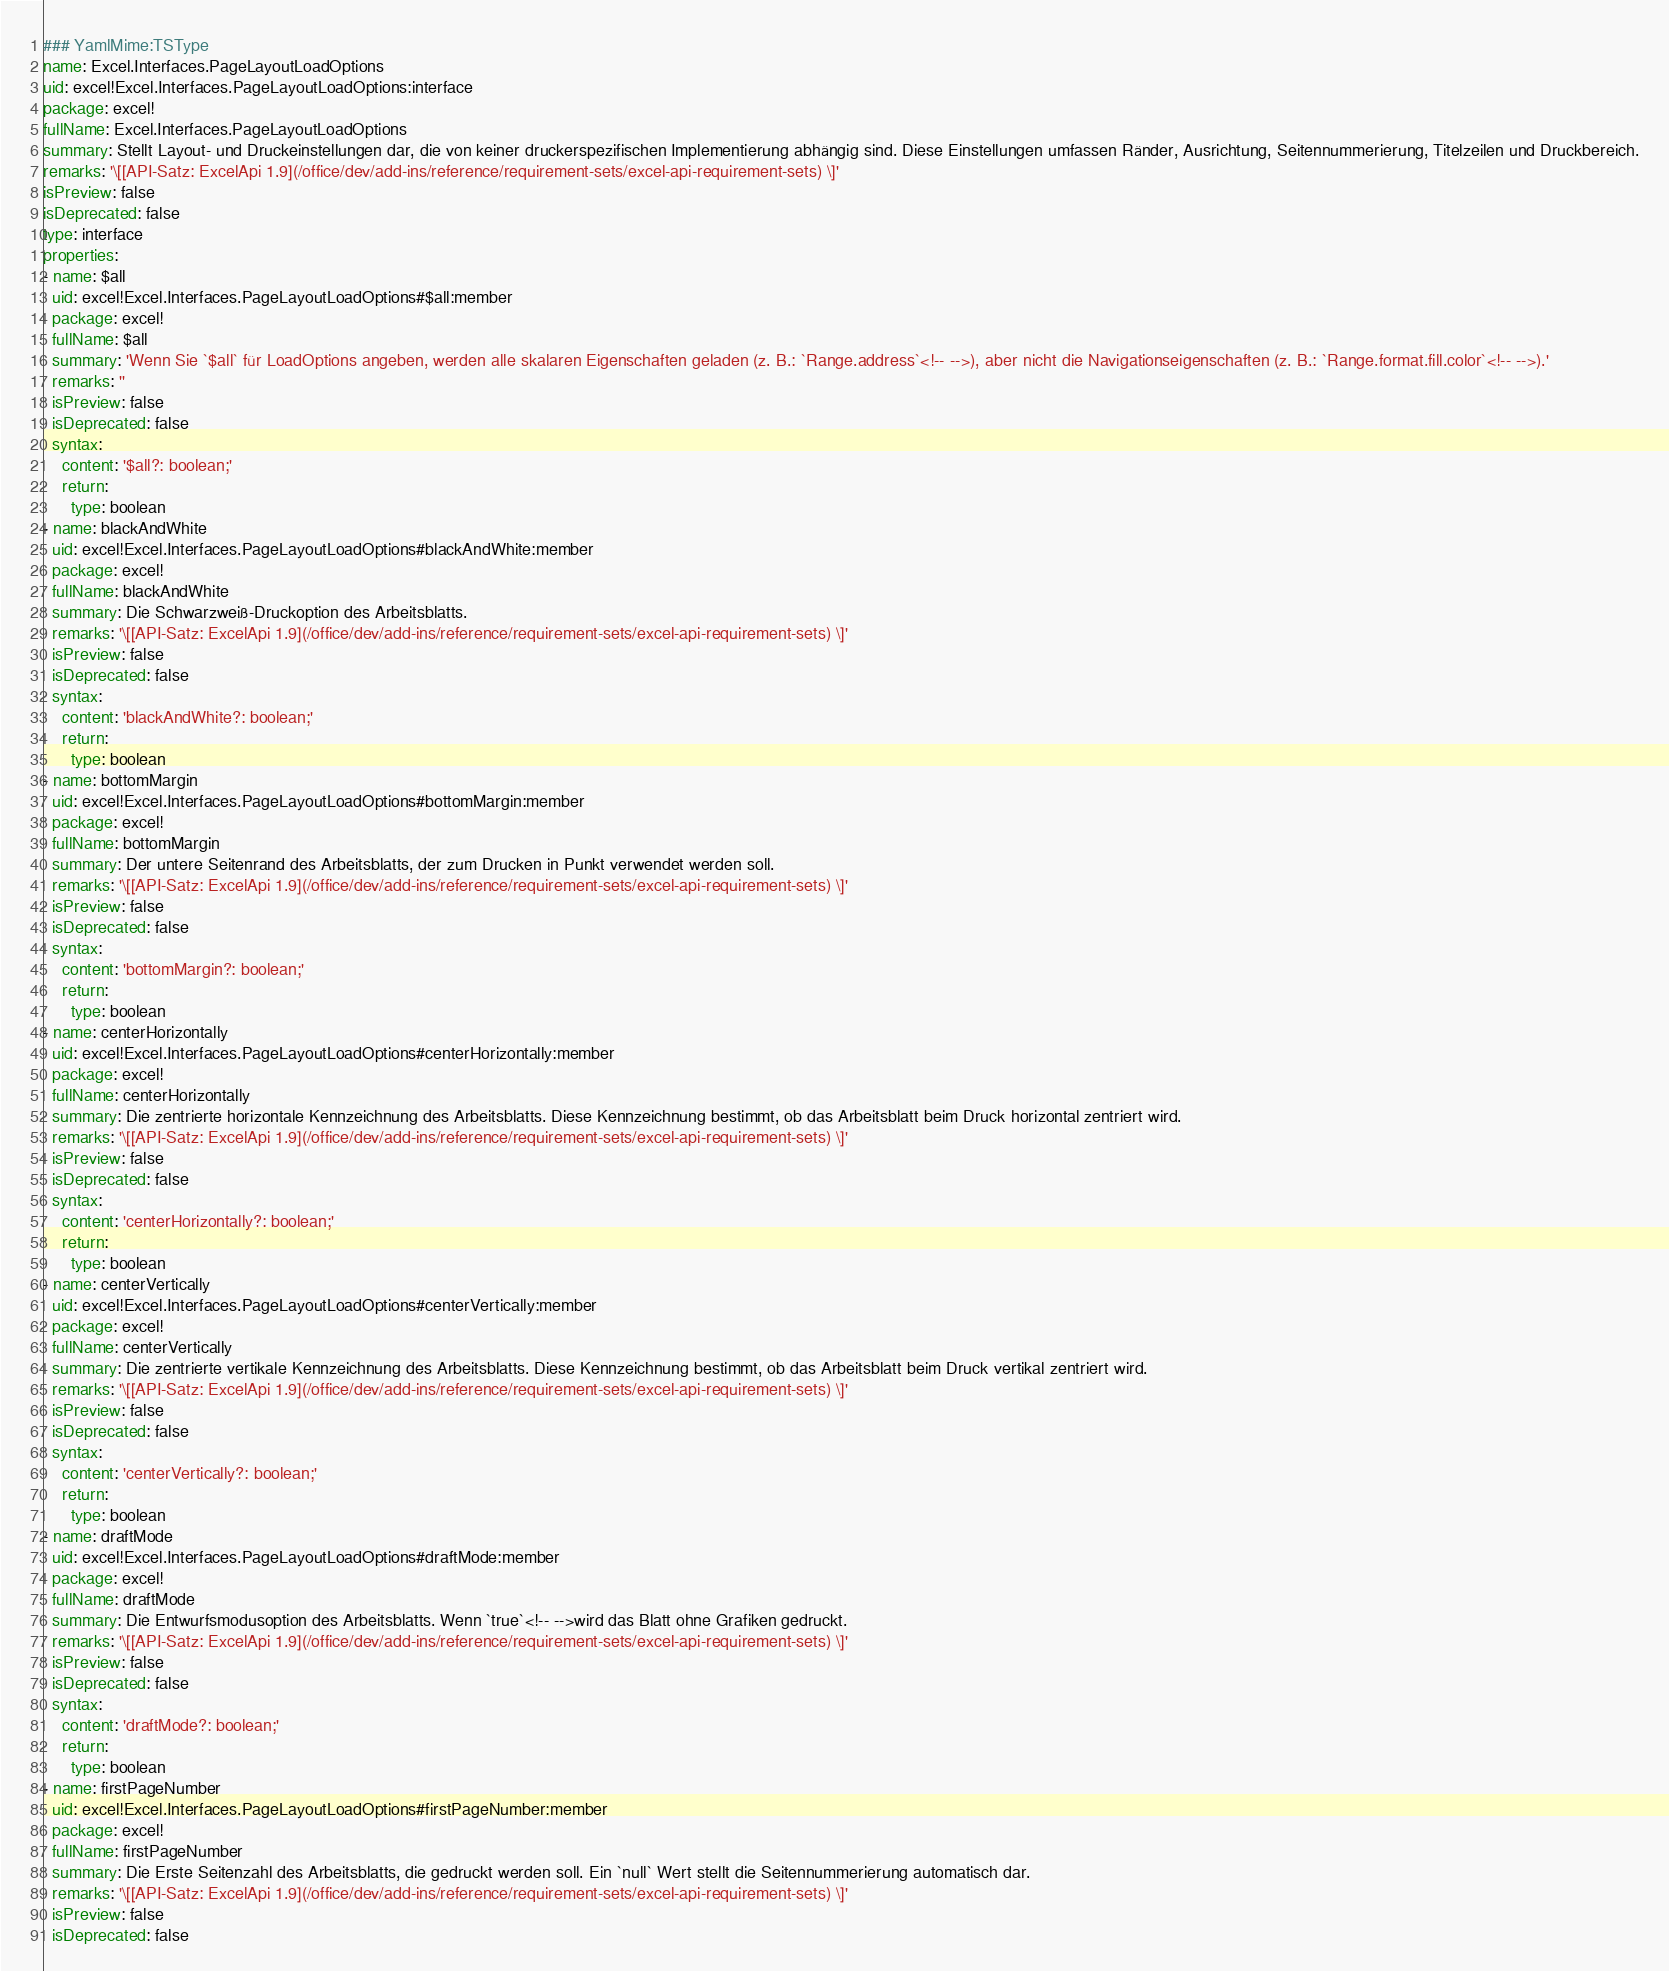<code> <loc_0><loc_0><loc_500><loc_500><_YAML_>### YamlMime:TSType
name: Excel.Interfaces.PageLayoutLoadOptions
uid: excel!Excel.Interfaces.PageLayoutLoadOptions:interface
package: excel!
fullName: Excel.Interfaces.PageLayoutLoadOptions
summary: Stellt Layout- und Druckeinstellungen dar, die von keiner druckerspezifischen Implementierung abhängig sind. Diese Einstellungen umfassen Ränder, Ausrichtung, Seitennummerierung, Titelzeilen und Druckbereich.
remarks: '\[[API-Satz: ExcelApi 1.9](/office/dev/add-ins/reference/requirement-sets/excel-api-requirement-sets) \]'
isPreview: false
isDeprecated: false
type: interface
properties:
- name: $all
  uid: excel!Excel.Interfaces.PageLayoutLoadOptions#$all:member
  package: excel!
  fullName: $all
  summary: 'Wenn Sie `$all` für LoadOptions angeben, werden alle skalaren Eigenschaften geladen (z. B.: `Range.address`<!-- -->), aber nicht die Navigationseigenschaften (z. B.: `Range.format.fill.color`<!-- -->).'
  remarks: ''
  isPreview: false
  isDeprecated: false
  syntax:
    content: '$all?: boolean;'
    return:
      type: boolean
- name: blackAndWhite
  uid: excel!Excel.Interfaces.PageLayoutLoadOptions#blackAndWhite:member
  package: excel!
  fullName: blackAndWhite
  summary: Die Schwarzweiß-Druckoption des Arbeitsblatts.
  remarks: '\[[API-Satz: ExcelApi 1.9](/office/dev/add-ins/reference/requirement-sets/excel-api-requirement-sets) \]'
  isPreview: false
  isDeprecated: false
  syntax:
    content: 'blackAndWhite?: boolean;'
    return:
      type: boolean
- name: bottomMargin
  uid: excel!Excel.Interfaces.PageLayoutLoadOptions#bottomMargin:member
  package: excel!
  fullName: bottomMargin
  summary: Der untere Seitenrand des Arbeitsblatts, der zum Drucken in Punkt verwendet werden soll.
  remarks: '\[[API-Satz: ExcelApi 1.9](/office/dev/add-ins/reference/requirement-sets/excel-api-requirement-sets) \]'
  isPreview: false
  isDeprecated: false
  syntax:
    content: 'bottomMargin?: boolean;'
    return:
      type: boolean
- name: centerHorizontally
  uid: excel!Excel.Interfaces.PageLayoutLoadOptions#centerHorizontally:member
  package: excel!
  fullName: centerHorizontally
  summary: Die zentrierte horizontale Kennzeichnung des Arbeitsblatts. Diese Kennzeichnung bestimmt, ob das Arbeitsblatt beim Druck horizontal zentriert wird.
  remarks: '\[[API-Satz: ExcelApi 1.9](/office/dev/add-ins/reference/requirement-sets/excel-api-requirement-sets) \]'
  isPreview: false
  isDeprecated: false
  syntax:
    content: 'centerHorizontally?: boolean;'
    return:
      type: boolean
- name: centerVertically
  uid: excel!Excel.Interfaces.PageLayoutLoadOptions#centerVertically:member
  package: excel!
  fullName: centerVertically
  summary: Die zentrierte vertikale Kennzeichnung des Arbeitsblatts. Diese Kennzeichnung bestimmt, ob das Arbeitsblatt beim Druck vertikal zentriert wird.
  remarks: '\[[API-Satz: ExcelApi 1.9](/office/dev/add-ins/reference/requirement-sets/excel-api-requirement-sets) \]'
  isPreview: false
  isDeprecated: false
  syntax:
    content: 'centerVertically?: boolean;'
    return:
      type: boolean
- name: draftMode
  uid: excel!Excel.Interfaces.PageLayoutLoadOptions#draftMode:member
  package: excel!
  fullName: draftMode
  summary: Die Entwurfsmodusoption des Arbeitsblatts. Wenn `true`<!-- -->wird das Blatt ohne Grafiken gedruckt.
  remarks: '\[[API-Satz: ExcelApi 1.9](/office/dev/add-ins/reference/requirement-sets/excel-api-requirement-sets) \]'
  isPreview: false
  isDeprecated: false
  syntax:
    content: 'draftMode?: boolean;'
    return:
      type: boolean
- name: firstPageNumber
  uid: excel!Excel.Interfaces.PageLayoutLoadOptions#firstPageNumber:member
  package: excel!
  fullName: firstPageNumber
  summary: Die Erste Seitenzahl des Arbeitsblatts, die gedruckt werden soll. Ein `null` Wert stellt die Seitennummerierung automatisch dar.
  remarks: '\[[API-Satz: ExcelApi 1.9](/office/dev/add-ins/reference/requirement-sets/excel-api-requirement-sets) \]'
  isPreview: false
  isDeprecated: false</code> 